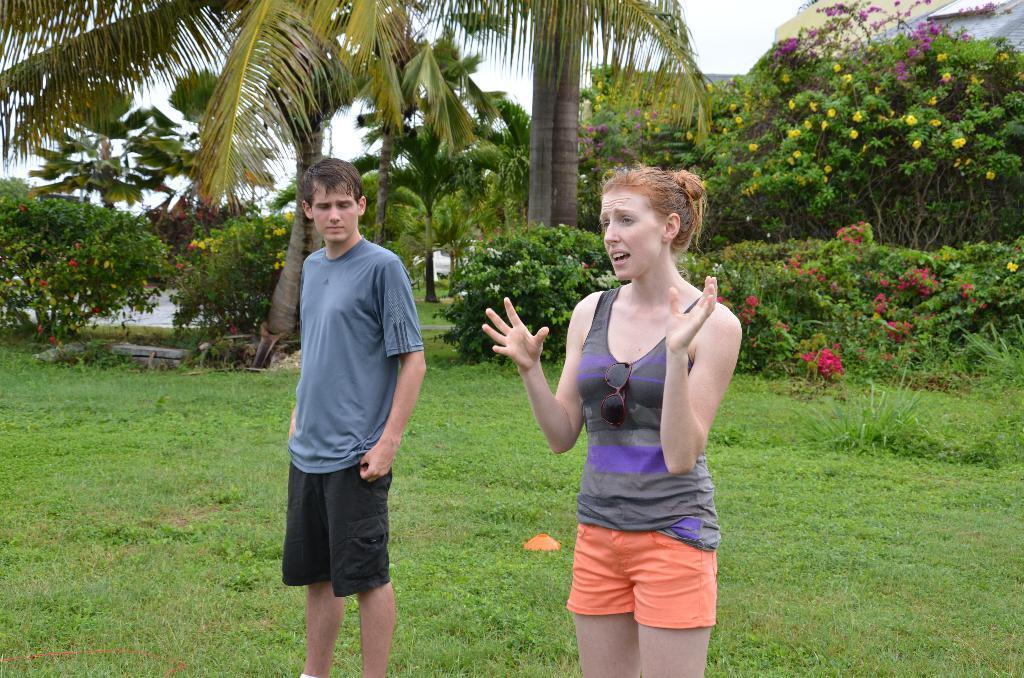Could you give a brief overview of what you see in this image? In this picture we can see a man and a woman standing on the grass and at the back of them we can see flowers, trees and some objects and in the background we can see the sky. 